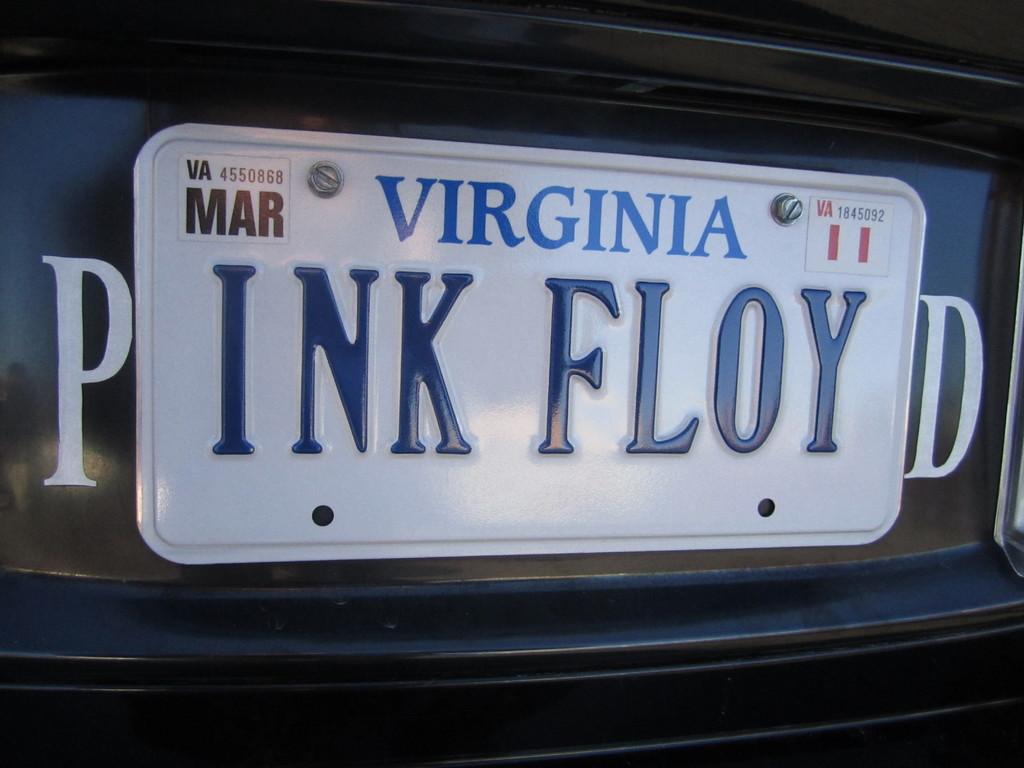What state is on the license plate?
Your answer should be very brief. Virginia. What does the license plate say?
Offer a terse response. Ink floy. 